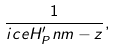<formula> <loc_0><loc_0><loc_500><loc_500>\frac { 1 } { \sl i c e { H ^ { \prime } _ { P } } { n } { m } - z } ,</formula> 